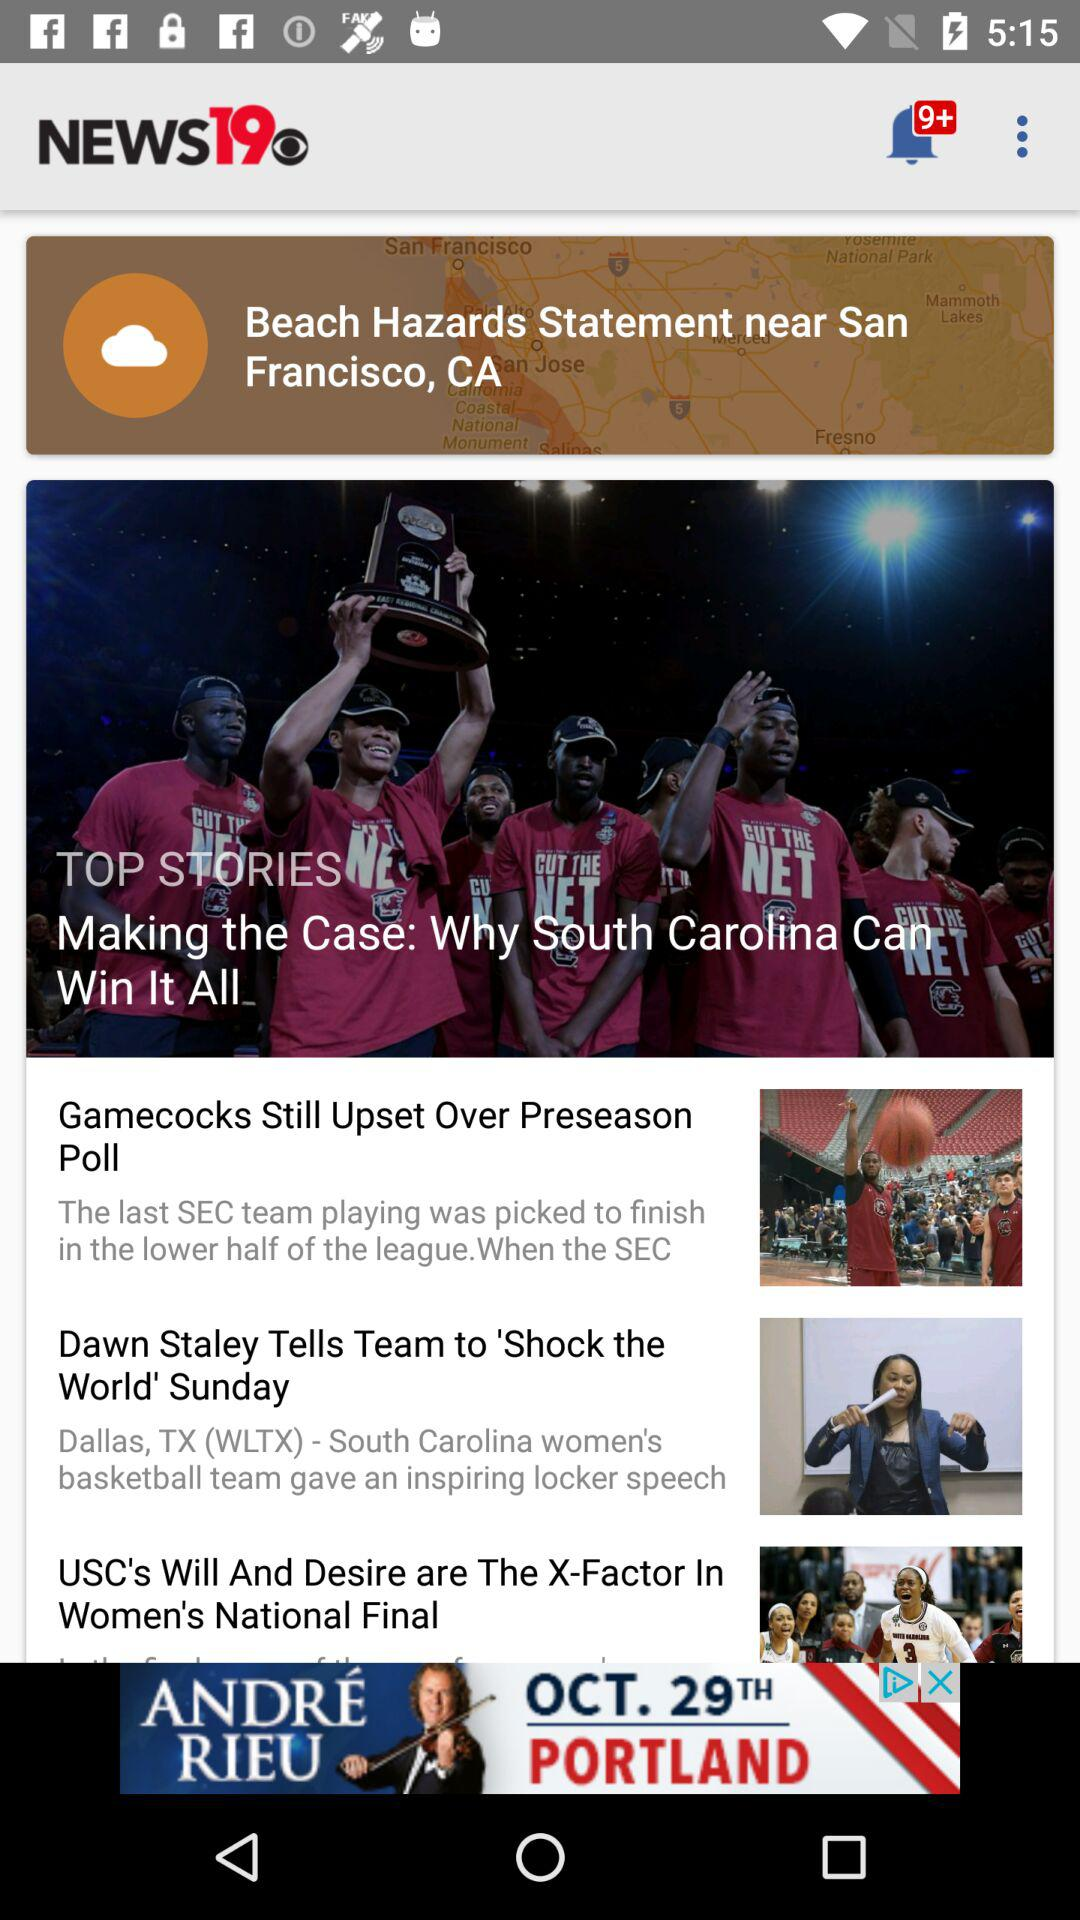What is the location shown on the screen? The location shown on the screen is San Francisco, CA. 